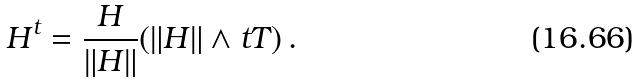<formula> <loc_0><loc_0><loc_500><loc_500>H ^ { t } = \frac { H } { \| H \| } ( \| H \| \wedge t T ) \, .</formula> 